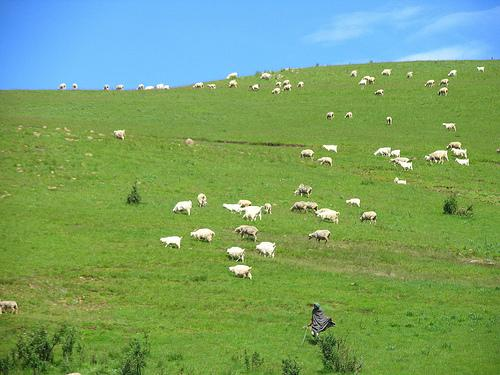What is the main activity happening in the image? A man with a cane is walking amongst a herd of sheep on a green hillside. What kind of landscape is the image illustrating? A pastoral scene with a shepherd man, sheep grazing on a green hill, and trees along the edge of the field. Mention the color and number of objects in sight in the image. Bright blue sky, few white clouds, many white sheep, green grass, green bushes, brown rocks, and a man with a green hat. Provide a brief summary of the contents of the image. A shepherd walks with his flock of sheep on a green grassy hill under a clear blue sky with few clouds, surrounded by bushes and trees. How would you describe the surroundings in the image from the perspective of a sheep? The world is a large, green, and grassy field full of delicious food, friends, and the kind shepherd who watches over us. Mention the primary features of the landscape in the image. A green grassy hill with many sheep, some bushes, and rocks, under a bright blue sky with white clouds. Describe the weather and the environment in the image. It is a sunny day with a bright blue sky and few white clouds, surrounded by green grassy fields and leafy trees. In a poetic way, describe the scenery of the image. Under the bright blue cloak of the sky, a shepherd roams with his flock of sheep, grazing on the vibrant hues of green, with trees whispering tales of the playful day. What are some noticeable details about the man in the image? The man is wearing a cap on his head and a long coverall, carrying a white cane and walking with the sheep. Describe the atmosphere and mood of the image. The image has a calm, peaceful, and relaxing atmosphere with a beautiful landscape and animals grazing in harmony. 